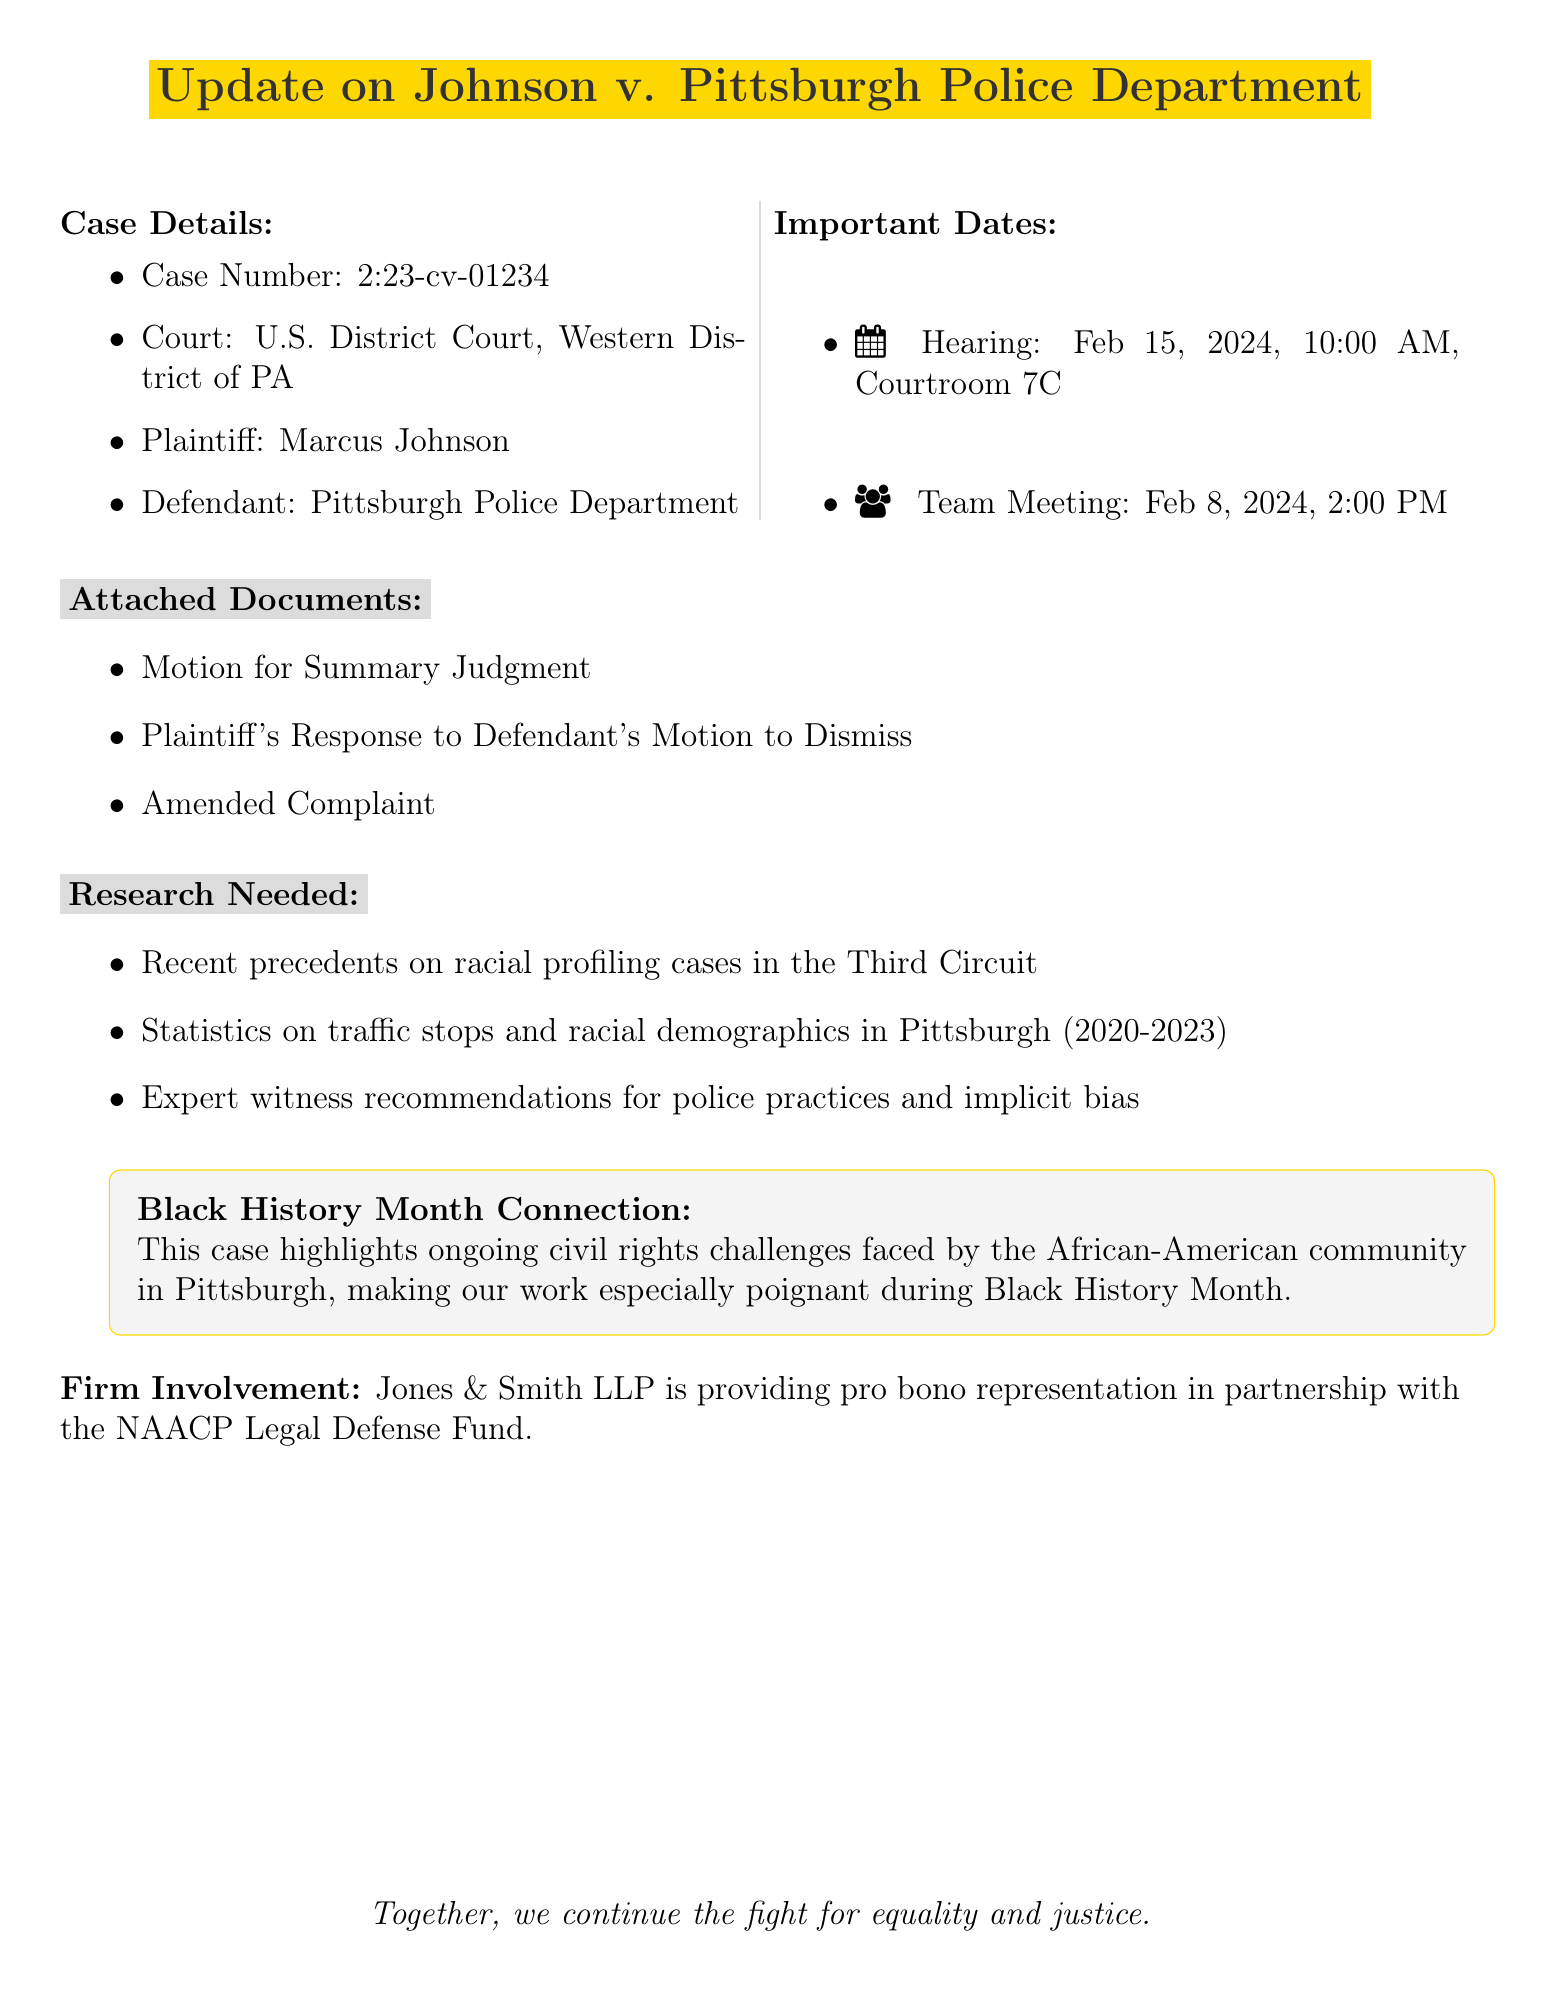what is the case number? The case number is explicitly listed in the document under Case Details.
Answer: 2:23-cv-01234 who is the plaintiff in the case? The document specifies the name of the plaintiff as part of the Case Details.
Answer: Marcus Johnson when is the hearing scheduled? The hearing date and time are clearly stated in the Important Dates section of the document.
Answer: February 15, 2024, at 10:00 AM what three documents are attached? The attached documents are explicitly listed in the document.
Answer: Motion for Summary Judgment, Plaintiff's Response to Defendant's Motion to Dismiss, Amended Complaint what is the connection to Black History Month? The document has a clear statement connecting the case to Black History Month.
Answer: Ongoing civil rights challenges faced by the African-American community in Pittsburgh what is the purpose of the team meeting scheduled on February 8, 2024? The document notes the purpose of the team meeting includes discussing research findings and hearing preparation.
Answer: Discuss research findings and hearing preparation which firm is providing pro bono representation? The document states which firm is involved in providing representation in the last section.
Answer: Jones & Smith LLP what type of research is needed? The document lists specific types of research needed related to the case.
Answer: Recent precedents on racial profiling cases in the Third Circuit, Statistics on traffic stops and racial demographics in Pittsburgh from 2020-2023, Expert witness recommendations for police practices and implicit bias 